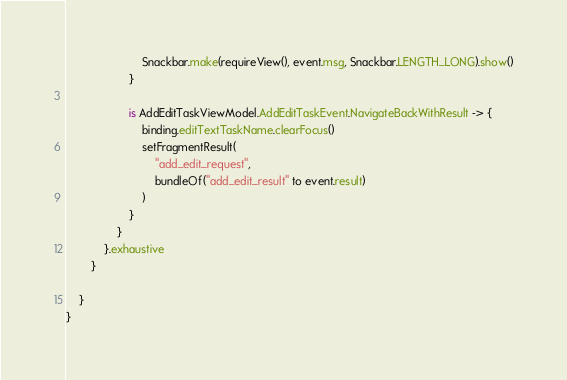Convert code to text. <code><loc_0><loc_0><loc_500><loc_500><_Kotlin_>                        Snackbar.make(requireView(), event.msg, Snackbar.LENGTH_LONG).show()
                    }

                    is AddEditTaskViewModel.AddEditTaskEvent.NavigateBackWithResult -> {
                        binding.editTextTaskName.clearFocus()
                        setFragmentResult(
                            "add_edit_request",
                            bundleOf("add_edit_result" to event.result)
                        )
                    }
                }
            }.exhaustive
        }

    }
}</code> 